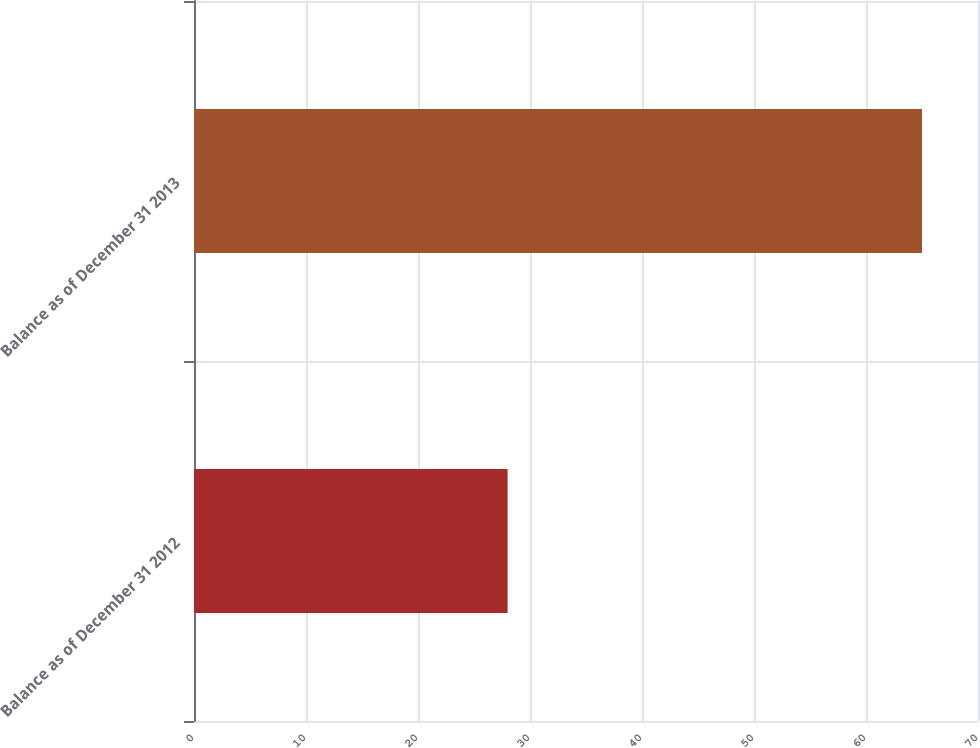Convert chart. <chart><loc_0><loc_0><loc_500><loc_500><bar_chart><fcel>Balance as of December 31 2012<fcel>Balance as of December 31 2013<nl><fcel>28<fcel>65<nl></chart> 